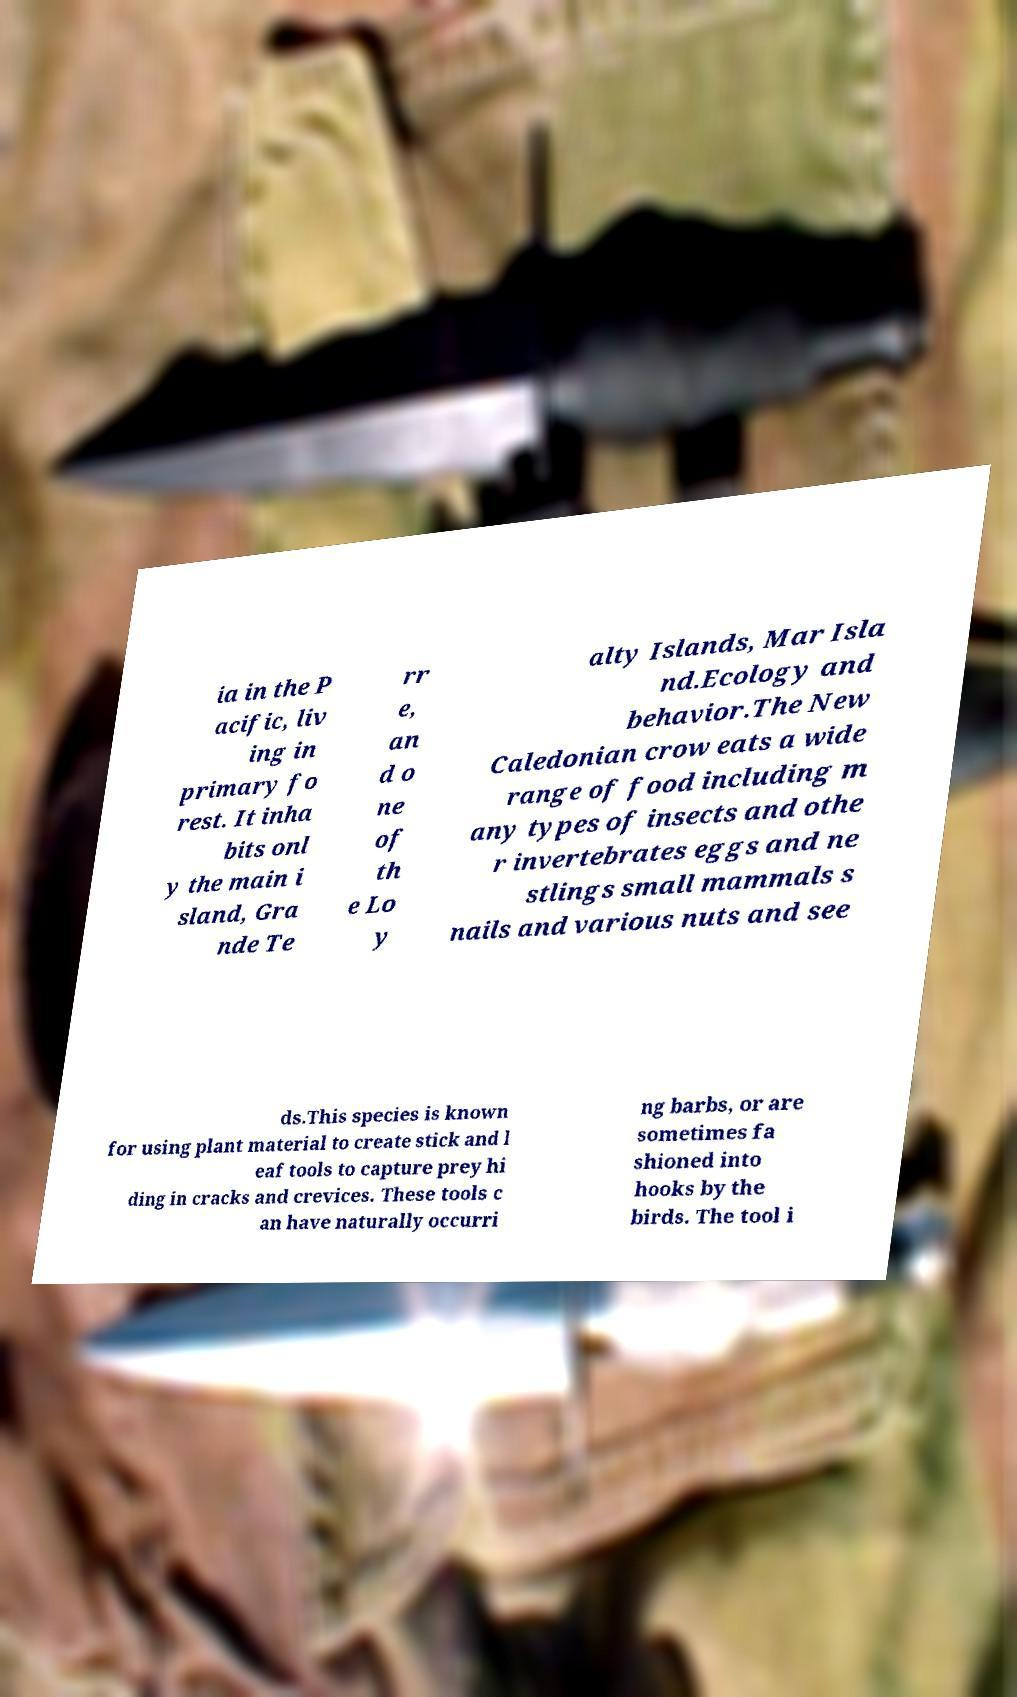For documentation purposes, I need the text within this image transcribed. Could you provide that? ia in the P acific, liv ing in primary fo rest. It inha bits onl y the main i sland, Gra nde Te rr e, an d o ne of th e Lo y alty Islands, Mar Isla nd.Ecology and behavior.The New Caledonian crow eats a wide range of food including m any types of insects and othe r invertebrates eggs and ne stlings small mammals s nails and various nuts and see ds.This species is known for using plant material to create stick and l eaf tools to capture prey hi ding in cracks and crevices. These tools c an have naturally occurri ng barbs, or are sometimes fa shioned into hooks by the birds. The tool i 